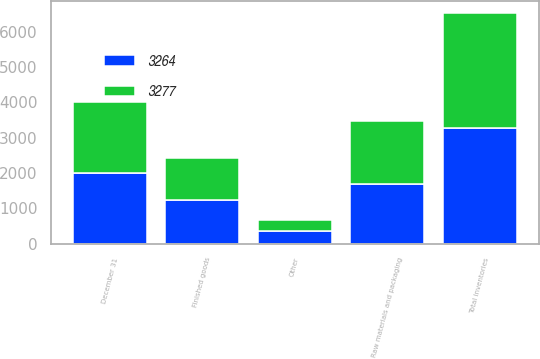Convert chart. <chart><loc_0><loc_0><loc_500><loc_500><stacked_bar_chart><ecel><fcel>December 31<fcel>Raw materials and packaging<fcel>Finished goods<fcel>Other<fcel>Total inventories<nl><fcel>3264<fcel>2013<fcel>1692<fcel>1240<fcel>345<fcel>3277<nl><fcel>3277<fcel>2012<fcel>1773<fcel>1171<fcel>320<fcel>3264<nl></chart> 